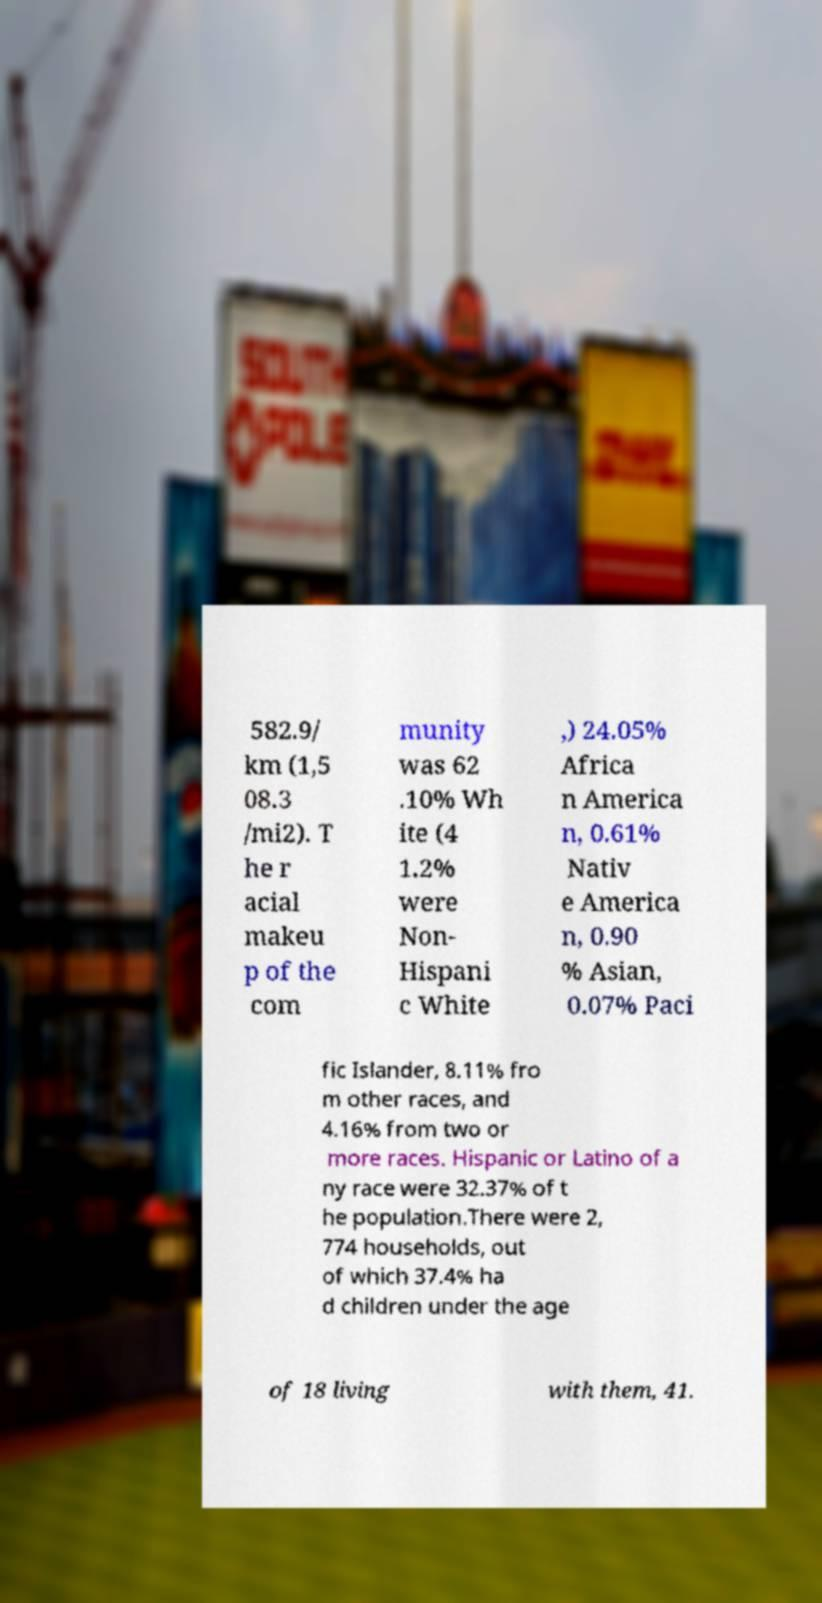Please identify and transcribe the text found in this image. 582.9/ km (1,5 08.3 /mi2). T he r acial makeu p of the com munity was 62 .10% Wh ite (4 1.2% were Non- Hispani c White ,) 24.05% Africa n America n, 0.61% Nativ e America n, 0.90 % Asian, 0.07% Paci fic Islander, 8.11% fro m other races, and 4.16% from two or more races. Hispanic or Latino of a ny race were 32.37% of t he population.There were 2, 774 households, out of which 37.4% ha d children under the age of 18 living with them, 41. 